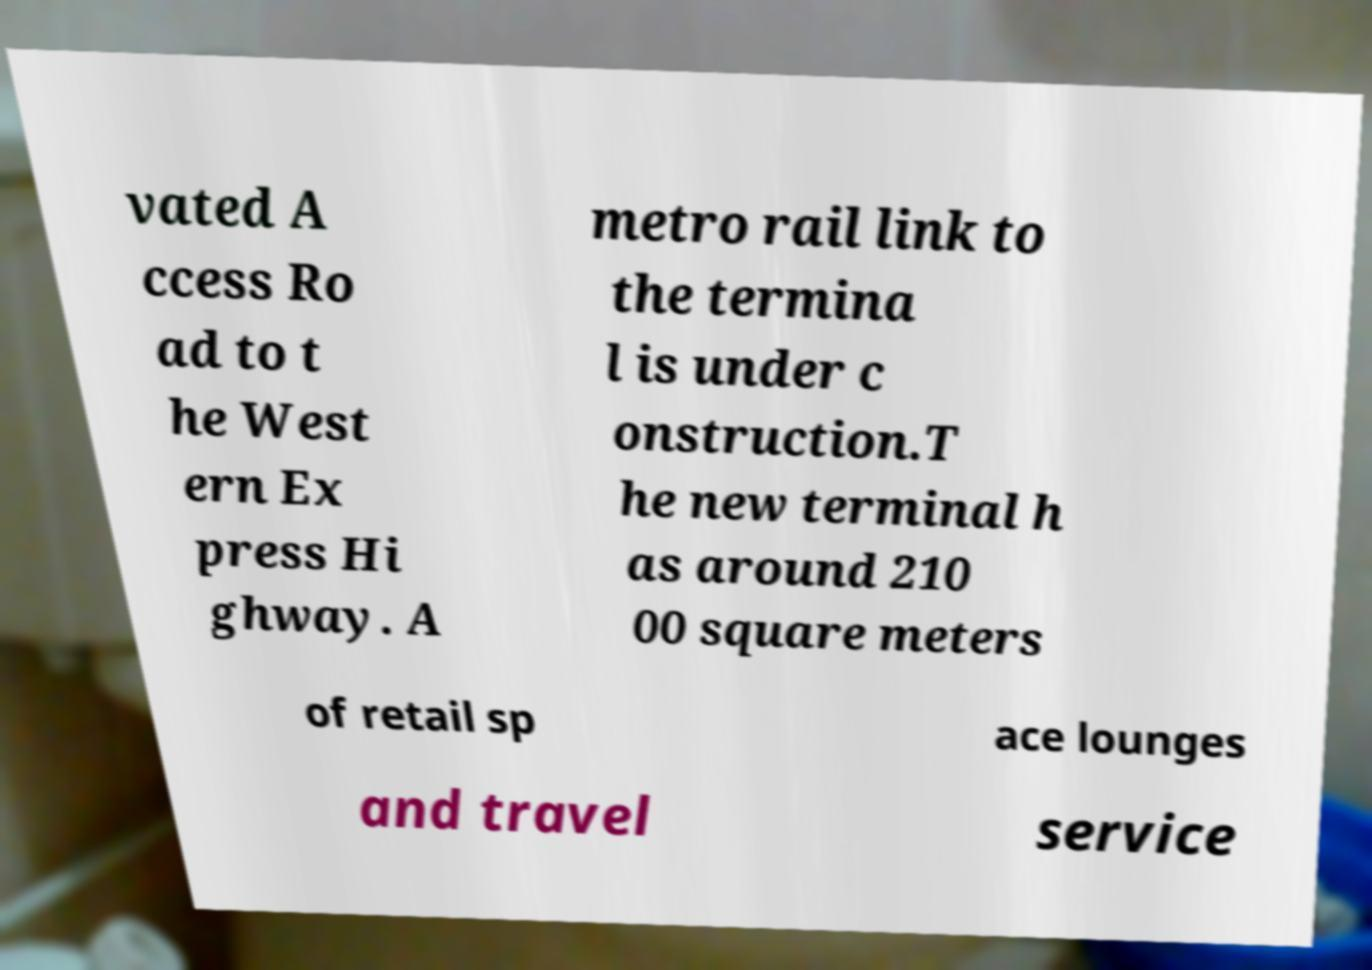Can you accurately transcribe the text from the provided image for me? vated A ccess Ro ad to t he West ern Ex press Hi ghway. A metro rail link to the termina l is under c onstruction.T he new terminal h as around 210 00 square meters of retail sp ace lounges and travel service 